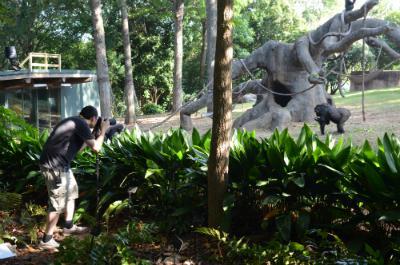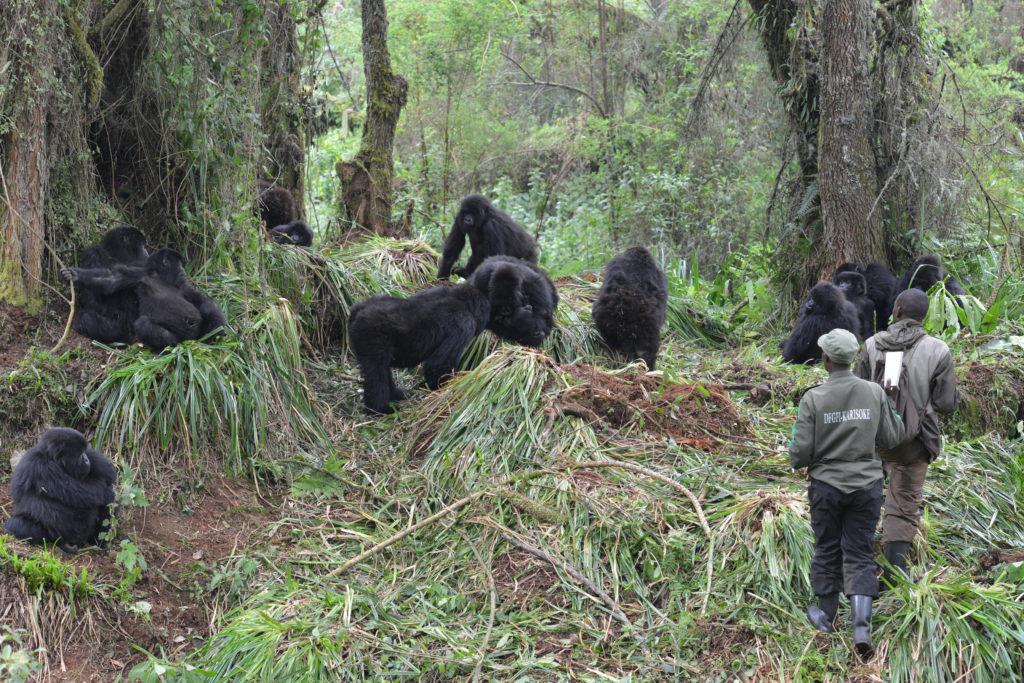The first image is the image on the left, the second image is the image on the right. Given the left and right images, does the statement "The right image contains no more than one gorilla." hold true? Answer yes or no. No. The first image is the image on the left, the second image is the image on the right. Considering the images on both sides, is "A camera-facing person is holding a notebook and standing near a group of gorillas in a forest." valid? Answer yes or no. No. 